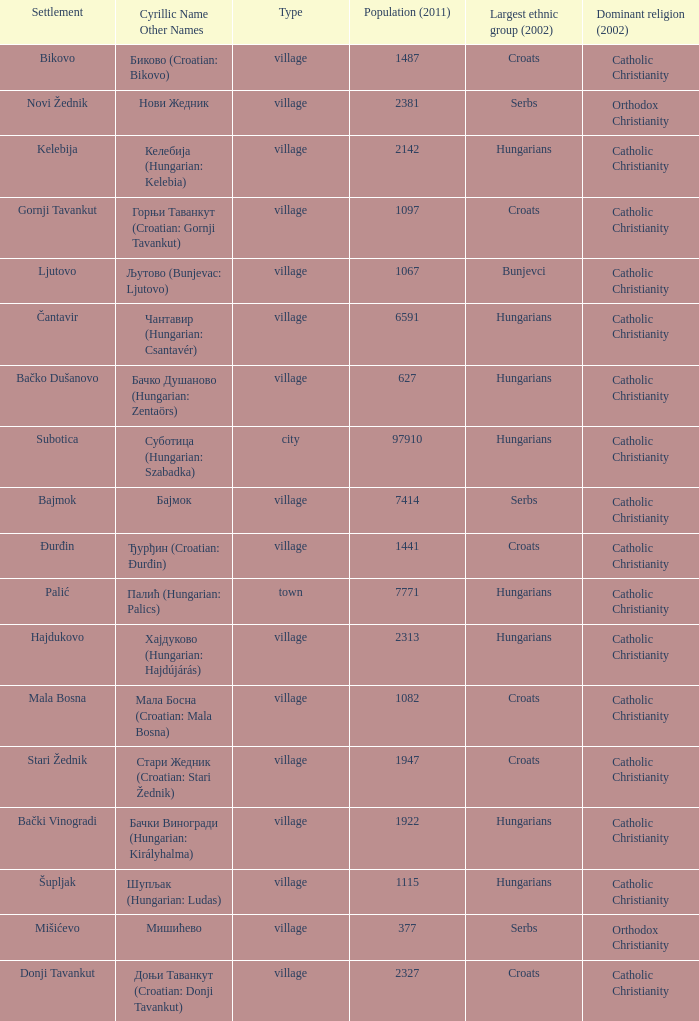How many settlements are named ђурђин (croatian: đurđin)? 1.0. 